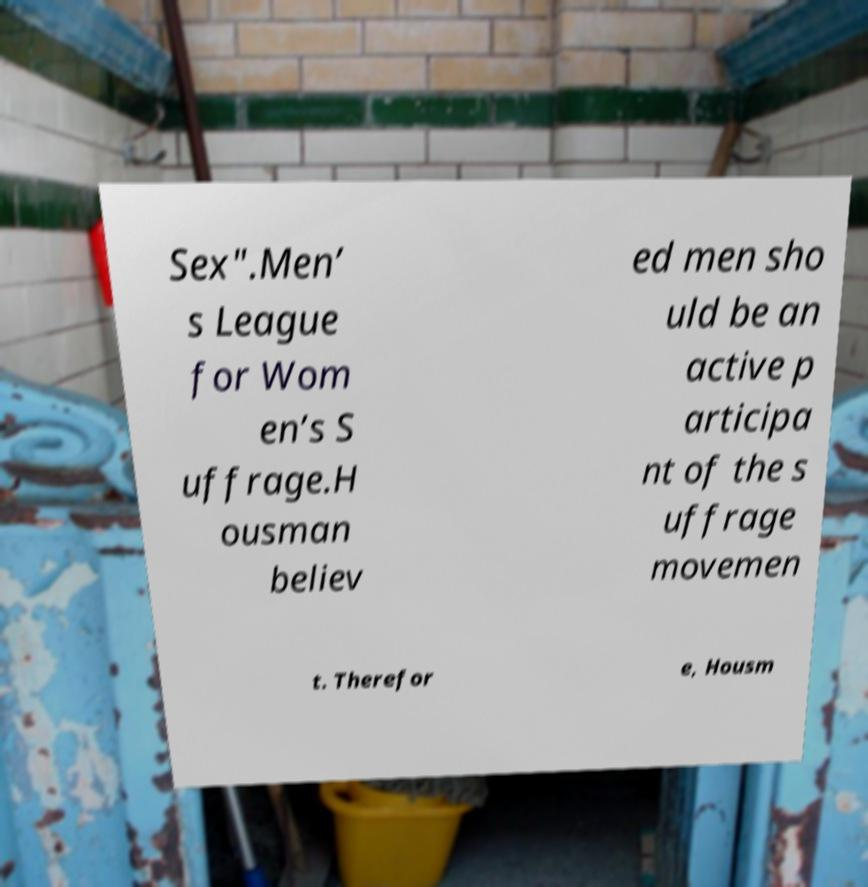I need the written content from this picture converted into text. Can you do that? Sex".Men’ s League for Wom en’s S uffrage.H ousman believ ed men sho uld be an active p articipa nt of the s uffrage movemen t. Therefor e, Housm 